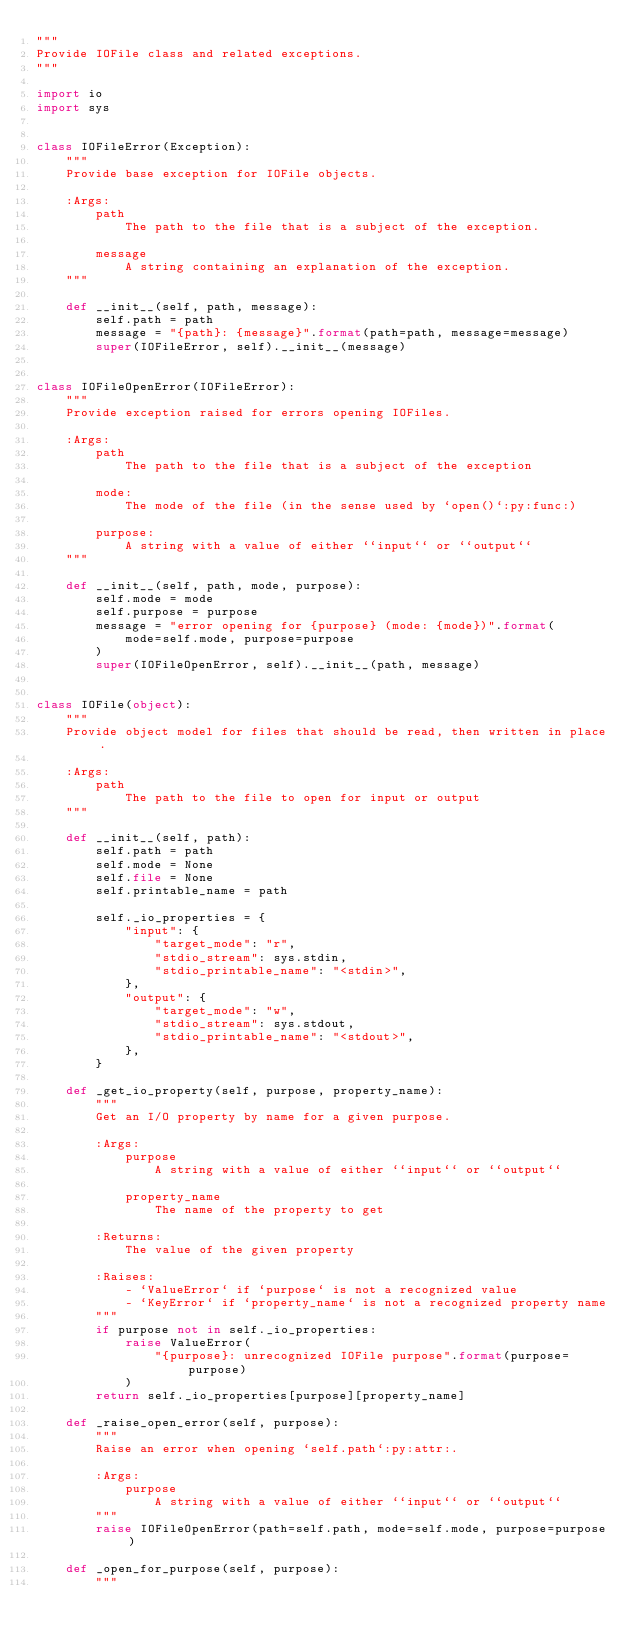<code> <loc_0><loc_0><loc_500><loc_500><_Python_>"""
Provide IOFile class and related exceptions.
"""

import io
import sys


class IOFileError(Exception):
    """
    Provide base exception for IOFile objects.

    :Args:
        path
            The path to the file that is a subject of the exception.

        message
            A string containing an explanation of the exception.
    """

    def __init__(self, path, message):
        self.path = path
        message = "{path}: {message}".format(path=path, message=message)
        super(IOFileError, self).__init__(message)


class IOFileOpenError(IOFileError):
    """
    Provide exception raised for errors opening IOFiles.

    :Args:
        path
            The path to the file that is a subject of the exception

        mode:
            The mode of the file (in the sense used by `open()`:py:func:)

        purpose:
            A string with a value of either ``input`` or ``output``
    """

    def __init__(self, path, mode, purpose):
        self.mode = mode
        self.purpose = purpose
        message = "error opening for {purpose} (mode: {mode})".format(
            mode=self.mode, purpose=purpose
        )
        super(IOFileOpenError, self).__init__(path, message)


class IOFile(object):
    """
    Provide object model for files that should be read, then written in place.

    :Args:
        path
            The path to the file to open for input or output
    """

    def __init__(self, path):
        self.path = path
        self.mode = None
        self.file = None
        self.printable_name = path

        self._io_properties = {
            "input": {
                "target_mode": "r",
                "stdio_stream": sys.stdin,
                "stdio_printable_name": "<stdin>",
            },
            "output": {
                "target_mode": "w",
                "stdio_stream": sys.stdout,
                "stdio_printable_name": "<stdout>",
            },
        }

    def _get_io_property(self, purpose, property_name):
        """
        Get an I/O property by name for a given purpose.

        :Args:
            purpose
                A string with a value of either ``input`` or ``output``

            property_name
                The name of the property to get

        :Returns:
            The value of the given property

        :Raises:
            - `ValueError` if `purpose` is not a recognized value
            - `KeyError` if `property_name` is not a recognized property name
        """
        if purpose not in self._io_properties:
            raise ValueError(
                "{purpose}: unrecognized IOFile purpose".format(purpose=purpose)
            )
        return self._io_properties[purpose][property_name]

    def _raise_open_error(self, purpose):
        """
        Raise an error when opening `self.path`:py:attr:.

        :Args:
            purpose
                A string with a value of either ``input`` or ``output``
        """
        raise IOFileOpenError(path=self.path, mode=self.mode, purpose=purpose)

    def _open_for_purpose(self, purpose):
        """</code> 